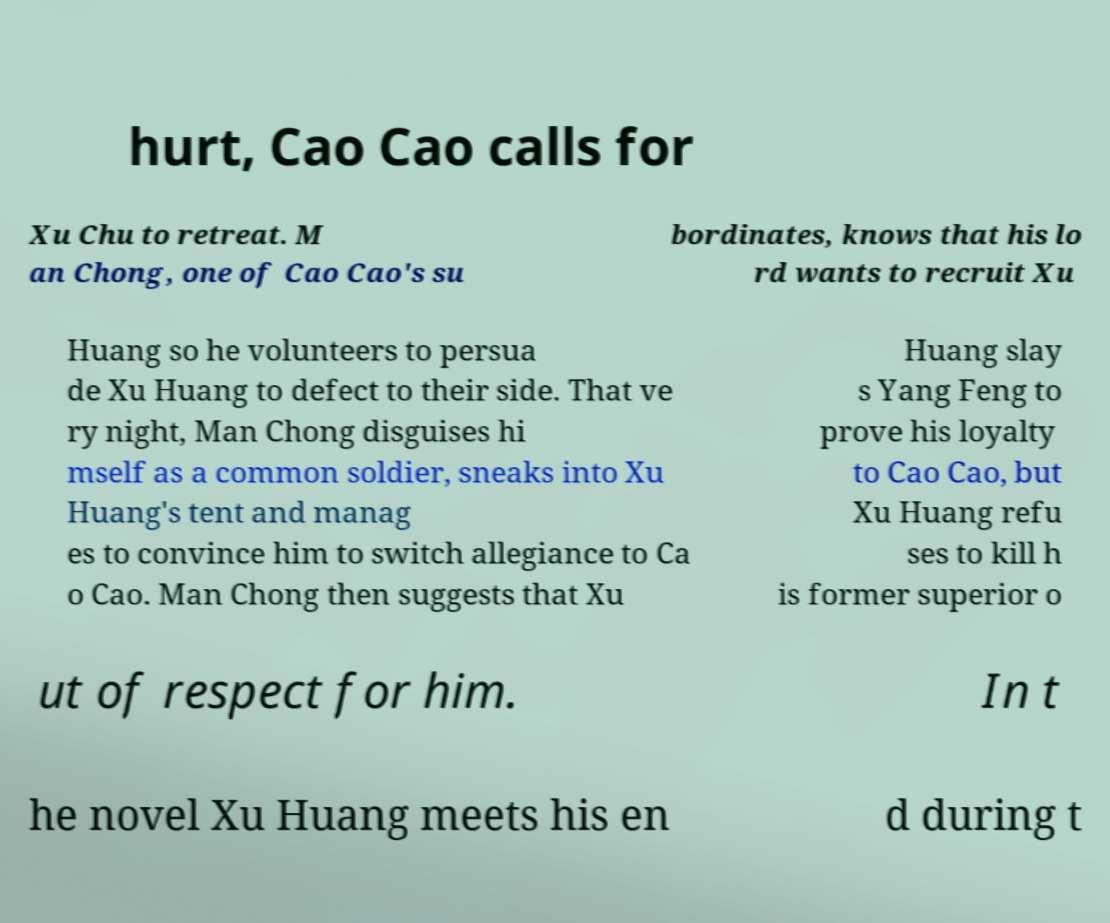There's text embedded in this image that I need extracted. Can you transcribe it verbatim? hurt, Cao Cao calls for Xu Chu to retreat. M an Chong, one of Cao Cao's su bordinates, knows that his lo rd wants to recruit Xu Huang so he volunteers to persua de Xu Huang to defect to their side. That ve ry night, Man Chong disguises hi mself as a common soldier, sneaks into Xu Huang's tent and manag es to convince him to switch allegiance to Ca o Cao. Man Chong then suggests that Xu Huang slay s Yang Feng to prove his loyalty to Cao Cao, but Xu Huang refu ses to kill h is former superior o ut of respect for him. In t he novel Xu Huang meets his en d during t 